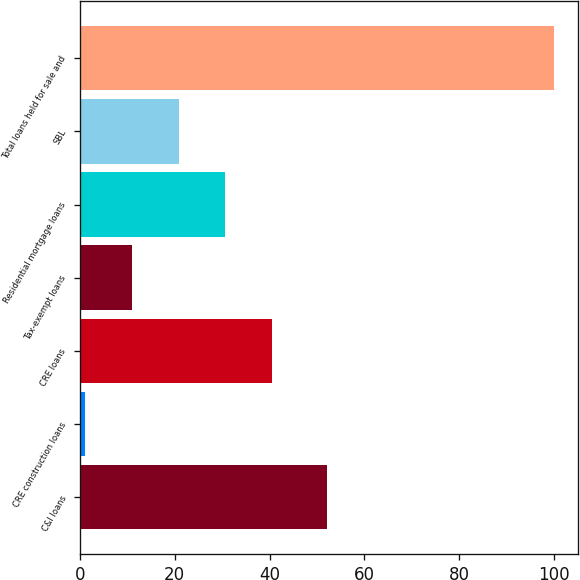Convert chart to OTSL. <chart><loc_0><loc_0><loc_500><loc_500><bar_chart><fcel>C&I loans<fcel>CRE construction loans<fcel>CRE loans<fcel>Tax-exempt loans<fcel>Residential mortgage loans<fcel>SBL<fcel>Total loans held for sale and<nl><fcel>52<fcel>1<fcel>40.6<fcel>10.9<fcel>30.7<fcel>20.8<fcel>100<nl></chart> 